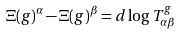<formula> <loc_0><loc_0><loc_500><loc_500>\Xi ( g ) ^ { \alpha } - \Xi ( g ) ^ { \beta } = d \log T _ { \alpha \beta } ^ { g }</formula> 